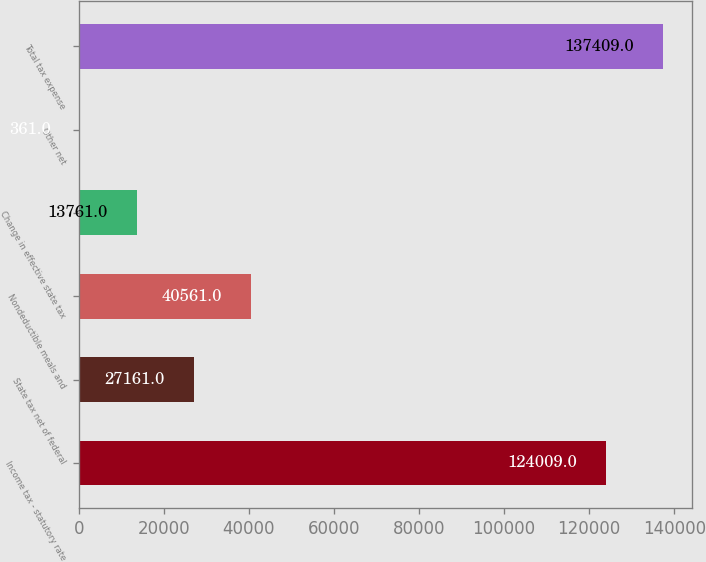Convert chart to OTSL. <chart><loc_0><loc_0><loc_500><loc_500><bar_chart><fcel>Income tax - statutory rate<fcel>State tax net of federal<fcel>Nondeductible meals and<fcel>Change in effective state tax<fcel>Other net<fcel>Total tax expense<nl><fcel>124009<fcel>27161<fcel>40561<fcel>13761<fcel>361<fcel>137409<nl></chart> 